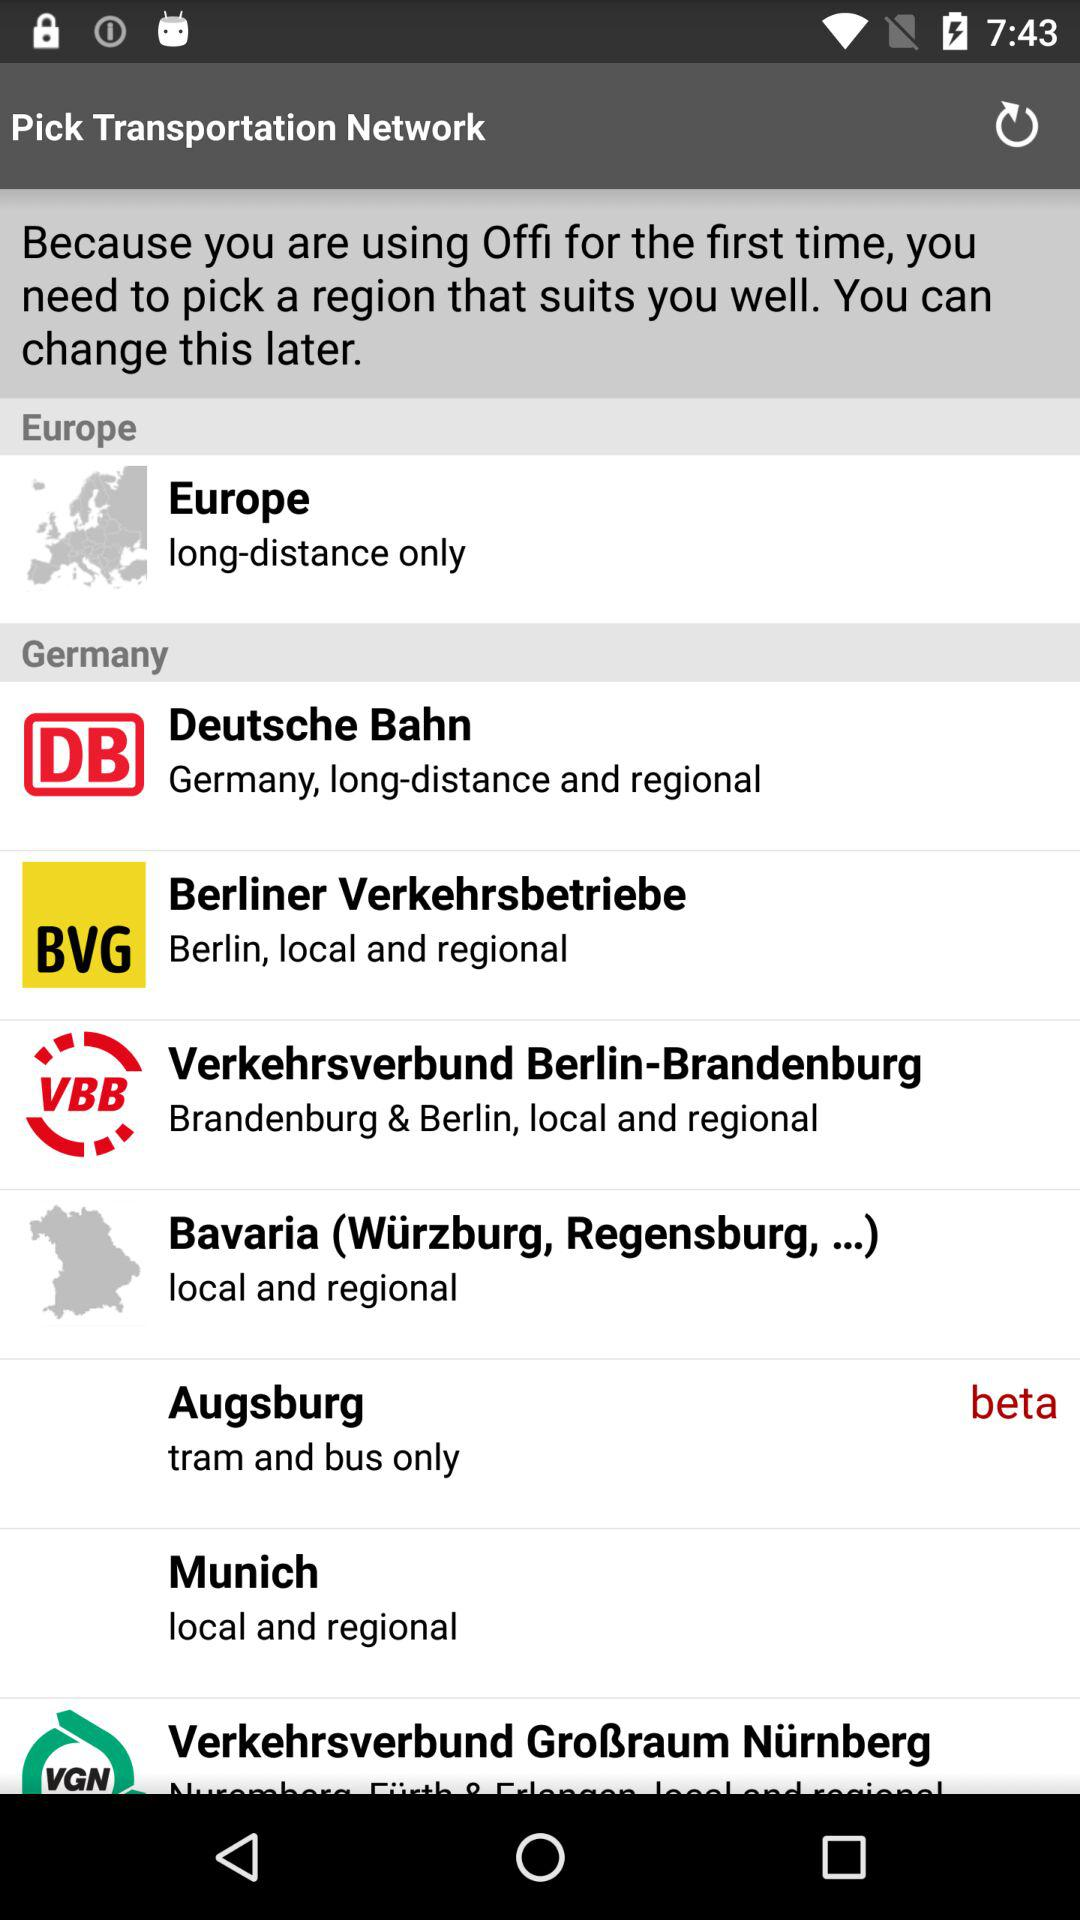Which available transportation network has tram and bus service? The transportation network that has tram and bus service is "Augsburg". 